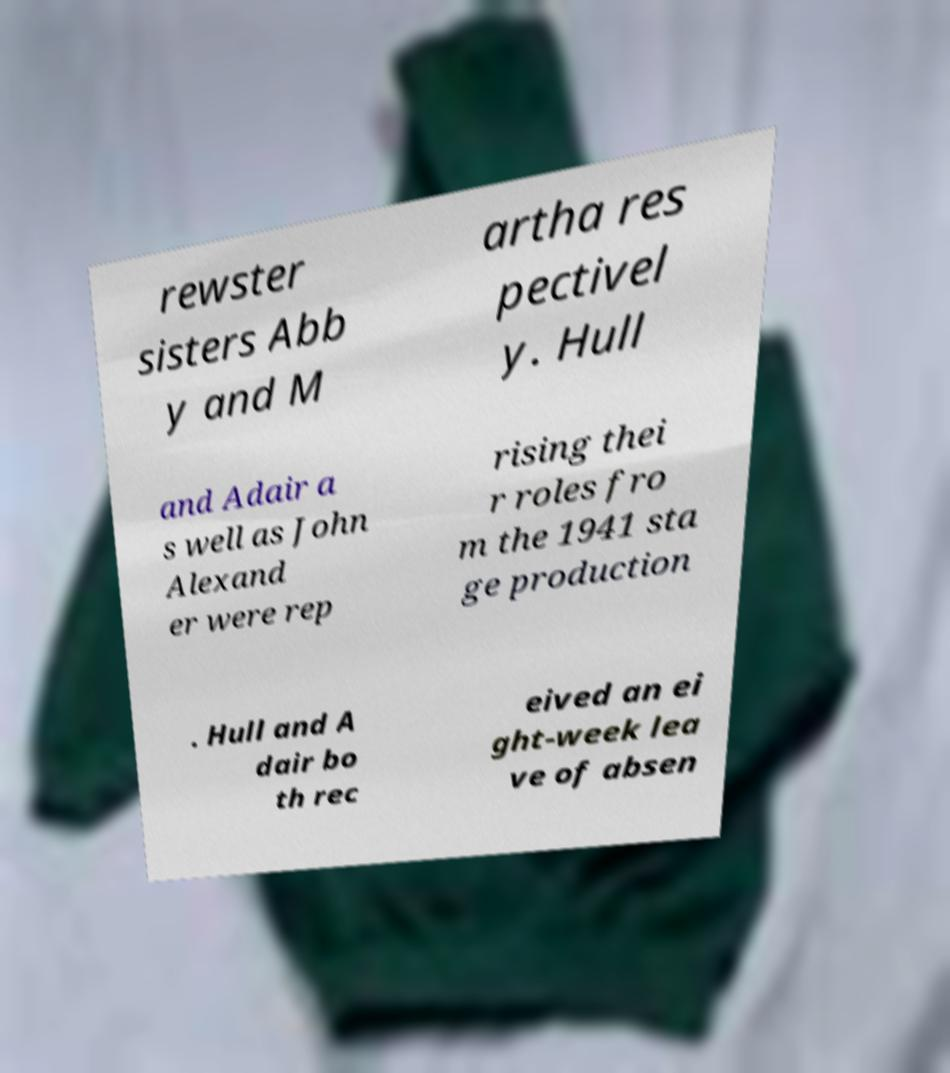Please read and relay the text visible in this image. What does it say? rewster sisters Abb y and M artha res pectivel y. Hull and Adair a s well as John Alexand er were rep rising thei r roles fro m the 1941 sta ge production . Hull and A dair bo th rec eived an ei ght-week lea ve of absen 